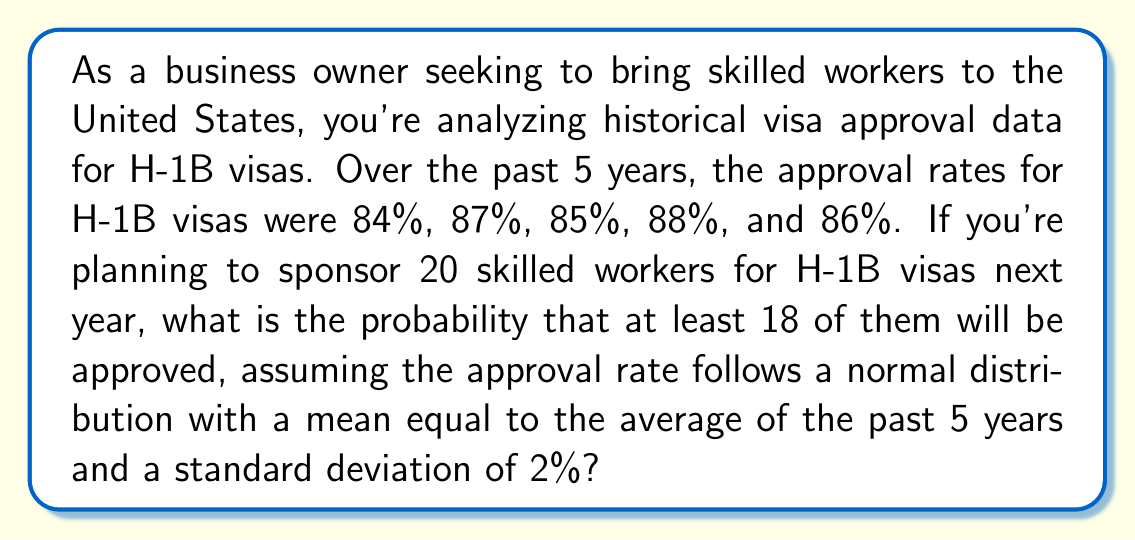Could you help me with this problem? To solve this problem, we'll follow these steps:

1) Calculate the mean approval rate:
   $$ \mu = \frac{84\% + 87\% + 85\% + 88\% + 86\%}{5} = 86\% $$

2) We're given that the standard deviation $\sigma = 2\%$

3) We want to find $P(X \geq 18)$ where $X$ is the number of approved visas out of 20 applications.

4) This follows a binomial distribution, but since $n = 20$ is large enough, we can approximate it with a normal distribution:
   $$ X \sim N(np, \sqrt{np(1-p)}) $$
   where $n = 20$ and $p = 86\% = 0.86$

5) Calculate the mean and standard deviation of this normal approximation:
   $$ \mu_X = np = 20 \times 0.86 = 17.2 $$
   $$ \sigma_X = \sqrt{np(1-p)} = \sqrt{20 \times 0.86 \times 0.14} \approx 1.5491 $$

6) We need to find $P(X \geq 18)$. First, we calculate the z-score:
   $$ z = \frac{18 - 17.2}{1.5491} \approx 0.5164 $$

7) Now, we need to find $P(Z > 0.5164)$ where $Z$ is the standard normal distribution.

8) Using a standard normal table or calculator, we find:
   $$ P(Z > 0.5164) \approx 0.3028 $$

Therefore, the probability of at least 18 out of 20 visa applications being approved is approximately 0.3028 or 30.28%.
Answer: The probability that at least 18 out of 20 H-1B visa applications will be approved is approximately 0.3028 or 30.28%. 